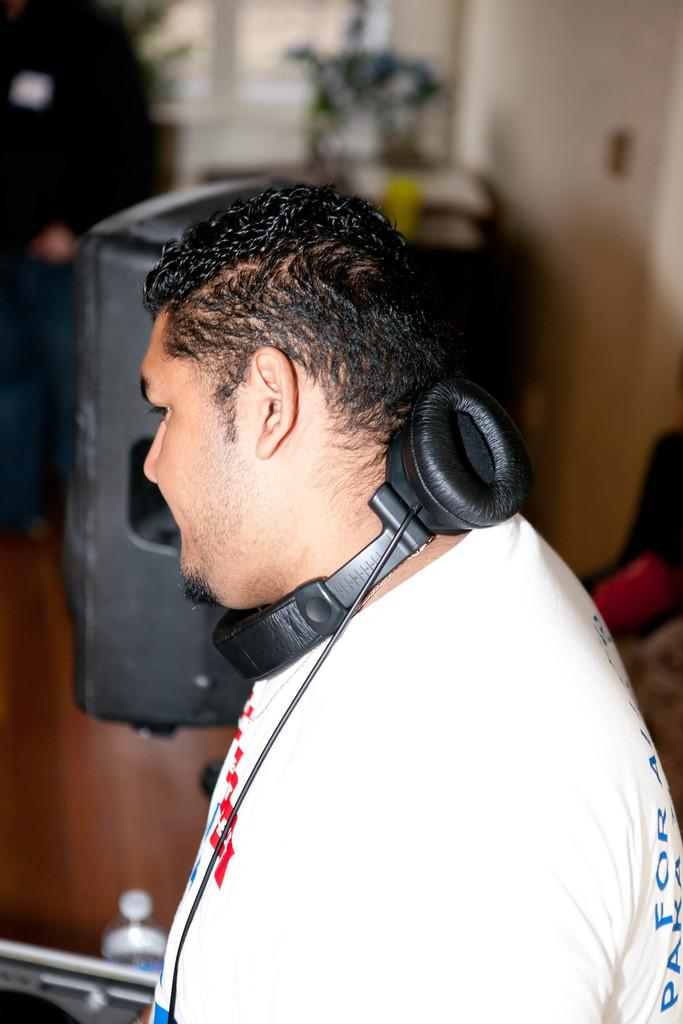Who is the main subject in the image? There is a man in the center of the image. What is the man wearing in the image? The man is wearing a headset in the image. What can be seen in the background of the image? There is a wall, a bottle, a table, and some objects in the background of the image. Can you see any jellyfish in the image? No, there are no jellyfish present in the image. What type of structure is the man standing in front of in the image? The provided facts do not mention any specific structure in the image, so we cannot determine the type of structure the man is standing in front of. 